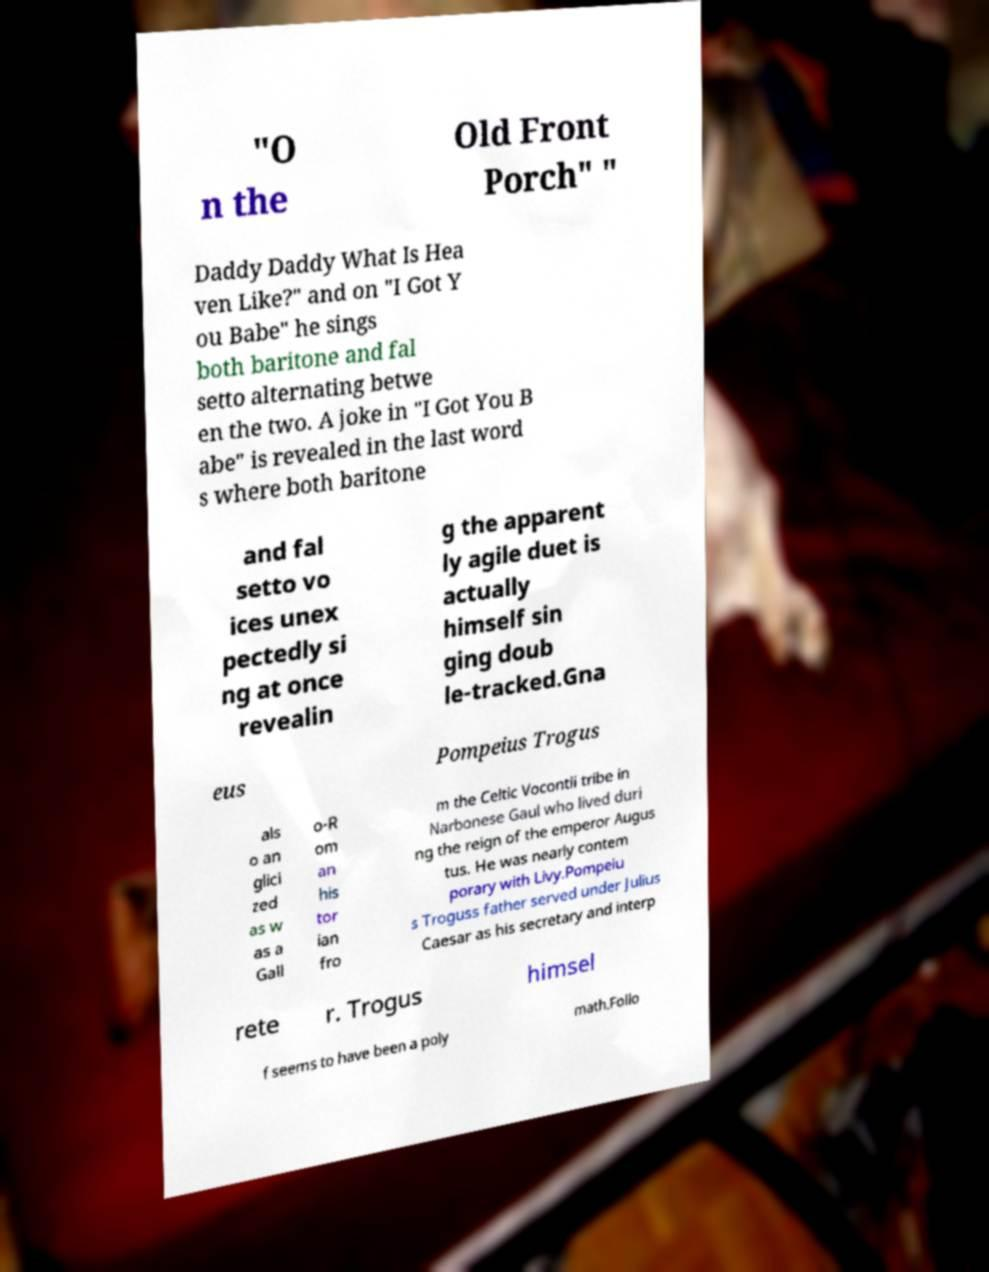There's text embedded in this image that I need extracted. Can you transcribe it verbatim? "O n the Old Front Porch" " Daddy Daddy What Is Hea ven Like?" and on "I Got Y ou Babe" he sings both baritone and fal setto alternating betwe en the two. A joke in "I Got You B abe" is revealed in the last word s where both baritone and fal setto vo ices unex pectedly si ng at once revealin g the apparent ly agile duet is actually himself sin ging doub le-tracked.Gna eus Pompeius Trogus als o an glici zed as w as a Gall o-R om an his tor ian fro m the Celtic Vocontii tribe in Narbonese Gaul who lived duri ng the reign of the emperor Augus tus. He was nearly contem porary with Livy.Pompeiu s Troguss father served under Julius Caesar as his secretary and interp rete r. Trogus himsel f seems to have been a poly math.Follo 